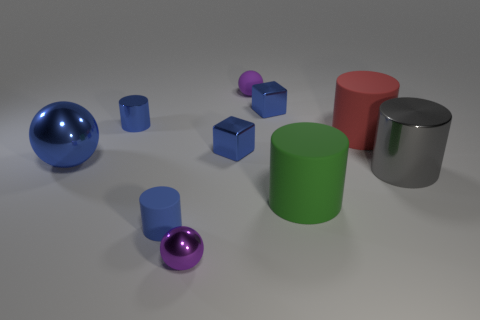Are the large green thing and the small purple ball behind the blue rubber cylinder made of the same material?
Keep it short and to the point. Yes. Is there another large object that has the same shape as the large red rubber object?
Ensure brevity in your answer.  Yes. What material is the gray cylinder that is the same size as the red rubber cylinder?
Your answer should be very brief. Metal. How big is the matte cylinder behind the large ball?
Give a very brief answer. Large. There is a blue shiny cylinder on the left side of the gray shiny cylinder; does it have the same size as the metallic cylinder on the right side of the red matte cylinder?
Provide a short and direct response. No. What number of tiny purple balls are made of the same material as the big gray object?
Provide a short and direct response. 1. What color is the small metal cylinder?
Your answer should be very brief. Blue. There is a large gray thing; are there any red rubber things in front of it?
Keep it short and to the point. No. Is the small metallic sphere the same color as the big sphere?
Offer a terse response. No. How many rubber balls are the same color as the tiny shiny sphere?
Offer a terse response. 1. 